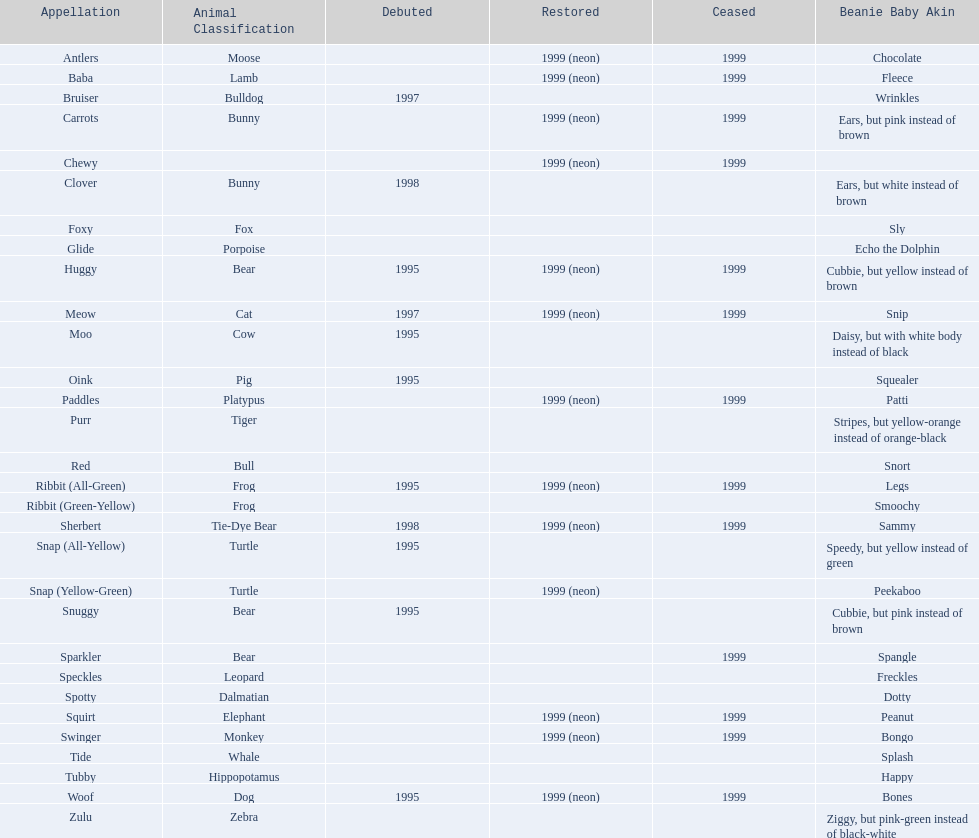What are all the pillow pals? Antlers, Baba, Bruiser, Carrots, Chewy, Clover, Foxy, Glide, Huggy, Meow, Moo, Oink, Paddles, Purr, Red, Ribbit (All-Green), Ribbit (Green-Yellow), Sherbert, Snap (All-Yellow), Snap (Yellow-Green), Snuggy, Sparkler, Speckles, Spotty, Squirt, Swinger, Tide, Tubby, Woof, Zulu. Which is the only without a listed animal type? Chewy. 